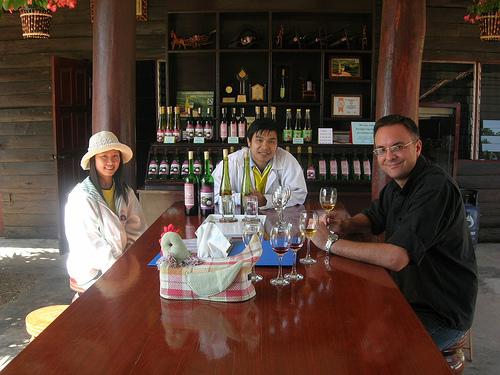What is the man in the background looking at?
Write a very short answer. Camera. What kind of glasses are on the table?
Short answer required. Wine. What are the people doing at the table?
Be succinct. Drinking. What are they drinking?
Concise answer only. Wine. What's in the basket?
Answer briefly. Bread. 